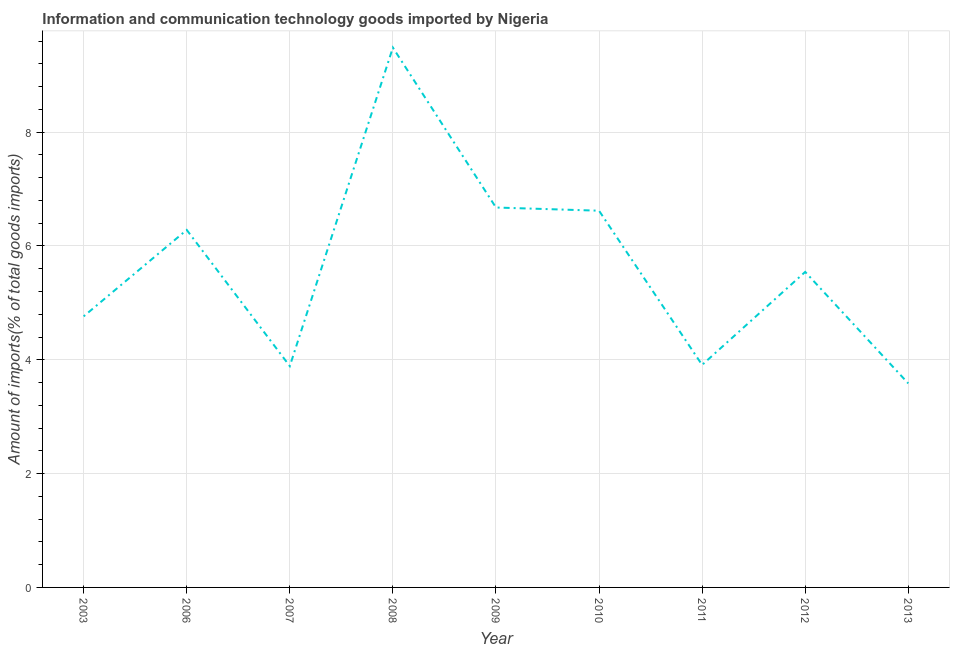What is the amount of ict goods imports in 2010?
Offer a very short reply. 6.62. Across all years, what is the maximum amount of ict goods imports?
Offer a very short reply. 9.49. Across all years, what is the minimum amount of ict goods imports?
Offer a very short reply. 3.59. In which year was the amount of ict goods imports minimum?
Your answer should be very brief. 2013. What is the sum of the amount of ict goods imports?
Your answer should be compact. 50.76. What is the difference between the amount of ict goods imports in 2011 and 2013?
Offer a terse response. 0.32. What is the average amount of ict goods imports per year?
Your answer should be compact. 5.64. What is the median amount of ict goods imports?
Provide a succinct answer. 5.54. Do a majority of the years between 2012 and 2007 (inclusive) have amount of ict goods imports greater than 6.8 %?
Offer a very short reply. Yes. What is the ratio of the amount of ict goods imports in 2011 to that in 2013?
Keep it short and to the point. 1.09. Is the amount of ict goods imports in 2007 less than that in 2013?
Your answer should be compact. No. What is the difference between the highest and the second highest amount of ict goods imports?
Give a very brief answer. 2.81. Is the sum of the amount of ict goods imports in 2009 and 2010 greater than the maximum amount of ict goods imports across all years?
Provide a short and direct response. Yes. What is the difference between the highest and the lowest amount of ict goods imports?
Offer a terse response. 5.9. In how many years, is the amount of ict goods imports greater than the average amount of ict goods imports taken over all years?
Give a very brief answer. 4. Does the amount of ict goods imports monotonically increase over the years?
Provide a short and direct response. No. How many lines are there?
Offer a terse response. 1. How many years are there in the graph?
Offer a very short reply. 9. What is the difference between two consecutive major ticks on the Y-axis?
Ensure brevity in your answer.  2. What is the title of the graph?
Your answer should be very brief. Information and communication technology goods imported by Nigeria. What is the label or title of the Y-axis?
Provide a short and direct response. Amount of imports(% of total goods imports). What is the Amount of imports(% of total goods imports) in 2003?
Provide a short and direct response. 4.76. What is the Amount of imports(% of total goods imports) of 2006?
Keep it short and to the point. 6.28. What is the Amount of imports(% of total goods imports) in 2007?
Your response must be concise. 3.89. What is the Amount of imports(% of total goods imports) in 2008?
Offer a very short reply. 9.49. What is the Amount of imports(% of total goods imports) in 2009?
Give a very brief answer. 6.68. What is the Amount of imports(% of total goods imports) in 2010?
Offer a terse response. 6.62. What is the Amount of imports(% of total goods imports) of 2011?
Your response must be concise. 3.91. What is the Amount of imports(% of total goods imports) of 2012?
Your response must be concise. 5.54. What is the Amount of imports(% of total goods imports) in 2013?
Give a very brief answer. 3.59. What is the difference between the Amount of imports(% of total goods imports) in 2003 and 2006?
Ensure brevity in your answer.  -1.52. What is the difference between the Amount of imports(% of total goods imports) in 2003 and 2007?
Offer a very short reply. 0.87. What is the difference between the Amount of imports(% of total goods imports) in 2003 and 2008?
Make the answer very short. -4.72. What is the difference between the Amount of imports(% of total goods imports) in 2003 and 2009?
Keep it short and to the point. -1.91. What is the difference between the Amount of imports(% of total goods imports) in 2003 and 2010?
Make the answer very short. -1.86. What is the difference between the Amount of imports(% of total goods imports) in 2003 and 2011?
Ensure brevity in your answer.  0.85. What is the difference between the Amount of imports(% of total goods imports) in 2003 and 2012?
Your answer should be compact. -0.78. What is the difference between the Amount of imports(% of total goods imports) in 2003 and 2013?
Make the answer very short. 1.18. What is the difference between the Amount of imports(% of total goods imports) in 2006 and 2007?
Your answer should be very brief. 2.39. What is the difference between the Amount of imports(% of total goods imports) in 2006 and 2008?
Your answer should be very brief. -3.2. What is the difference between the Amount of imports(% of total goods imports) in 2006 and 2009?
Provide a short and direct response. -0.39. What is the difference between the Amount of imports(% of total goods imports) in 2006 and 2010?
Offer a terse response. -0.34. What is the difference between the Amount of imports(% of total goods imports) in 2006 and 2011?
Offer a terse response. 2.37. What is the difference between the Amount of imports(% of total goods imports) in 2006 and 2012?
Provide a short and direct response. 0.74. What is the difference between the Amount of imports(% of total goods imports) in 2006 and 2013?
Give a very brief answer. 2.7. What is the difference between the Amount of imports(% of total goods imports) in 2007 and 2008?
Keep it short and to the point. -5.6. What is the difference between the Amount of imports(% of total goods imports) in 2007 and 2009?
Offer a terse response. -2.79. What is the difference between the Amount of imports(% of total goods imports) in 2007 and 2010?
Your response must be concise. -2.73. What is the difference between the Amount of imports(% of total goods imports) in 2007 and 2011?
Offer a very short reply. -0.02. What is the difference between the Amount of imports(% of total goods imports) in 2007 and 2012?
Offer a terse response. -1.66. What is the difference between the Amount of imports(% of total goods imports) in 2007 and 2013?
Make the answer very short. 0.3. What is the difference between the Amount of imports(% of total goods imports) in 2008 and 2009?
Your response must be concise. 2.81. What is the difference between the Amount of imports(% of total goods imports) in 2008 and 2010?
Make the answer very short. 2.87. What is the difference between the Amount of imports(% of total goods imports) in 2008 and 2011?
Make the answer very short. 5.58. What is the difference between the Amount of imports(% of total goods imports) in 2008 and 2012?
Keep it short and to the point. 3.94. What is the difference between the Amount of imports(% of total goods imports) in 2008 and 2013?
Offer a very short reply. 5.9. What is the difference between the Amount of imports(% of total goods imports) in 2009 and 2010?
Give a very brief answer. 0.06. What is the difference between the Amount of imports(% of total goods imports) in 2009 and 2011?
Offer a very short reply. 2.77. What is the difference between the Amount of imports(% of total goods imports) in 2009 and 2012?
Offer a terse response. 1.13. What is the difference between the Amount of imports(% of total goods imports) in 2009 and 2013?
Provide a succinct answer. 3.09. What is the difference between the Amount of imports(% of total goods imports) in 2010 and 2011?
Ensure brevity in your answer.  2.71. What is the difference between the Amount of imports(% of total goods imports) in 2010 and 2012?
Your answer should be compact. 1.08. What is the difference between the Amount of imports(% of total goods imports) in 2010 and 2013?
Make the answer very short. 3.03. What is the difference between the Amount of imports(% of total goods imports) in 2011 and 2012?
Offer a terse response. -1.63. What is the difference between the Amount of imports(% of total goods imports) in 2011 and 2013?
Give a very brief answer. 0.32. What is the difference between the Amount of imports(% of total goods imports) in 2012 and 2013?
Give a very brief answer. 1.96. What is the ratio of the Amount of imports(% of total goods imports) in 2003 to that in 2006?
Keep it short and to the point. 0.76. What is the ratio of the Amount of imports(% of total goods imports) in 2003 to that in 2007?
Offer a very short reply. 1.23. What is the ratio of the Amount of imports(% of total goods imports) in 2003 to that in 2008?
Keep it short and to the point. 0.5. What is the ratio of the Amount of imports(% of total goods imports) in 2003 to that in 2009?
Offer a terse response. 0.71. What is the ratio of the Amount of imports(% of total goods imports) in 2003 to that in 2010?
Your answer should be compact. 0.72. What is the ratio of the Amount of imports(% of total goods imports) in 2003 to that in 2011?
Keep it short and to the point. 1.22. What is the ratio of the Amount of imports(% of total goods imports) in 2003 to that in 2012?
Offer a very short reply. 0.86. What is the ratio of the Amount of imports(% of total goods imports) in 2003 to that in 2013?
Make the answer very short. 1.33. What is the ratio of the Amount of imports(% of total goods imports) in 2006 to that in 2007?
Your answer should be very brief. 1.61. What is the ratio of the Amount of imports(% of total goods imports) in 2006 to that in 2008?
Provide a short and direct response. 0.66. What is the ratio of the Amount of imports(% of total goods imports) in 2006 to that in 2009?
Your response must be concise. 0.94. What is the ratio of the Amount of imports(% of total goods imports) in 2006 to that in 2010?
Your response must be concise. 0.95. What is the ratio of the Amount of imports(% of total goods imports) in 2006 to that in 2011?
Ensure brevity in your answer.  1.61. What is the ratio of the Amount of imports(% of total goods imports) in 2006 to that in 2012?
Provide a short and direct response. 1.13. What is the ratio of the Amount of imports(% of total goods imports) in 2006 to that in 2013?
Your answer should be compact. 1.75. What is the ratio of the Amount of imports(% of total goods imports) in 2007 to that in 2008?
Provide a succinct answer. 0.41. What is the ratio of the Amount of imports(% of total goods imports) in 2007 to that in 2009?
Make the answer very short. 0.58. What is the ratio of the Amount of imports(% of total goods imports) in 2007 to that in 2010?
Your answer should be compact. 0.59. What is the ratio of the Amount of imports(% of total goods imports) in 2007 to that in 2012?
Your answer should be very brief. 0.7. What is the ratio of the Amount of imports(% of total goods imports) in 2007 to that in 2013?
Ensure brevity in your answer.  1.08. What is the ratio of the Amount of imports(% of total goods imports) in 2008 to that in 2009?
Make the answer very short. 1.42. What is the ratio of the Amount of imports(% of total goods imports) in 2008 to that in 2010?
Your response must be concise. 1.43. What is the ratio of the Amount of imports(% of total goods imports) in 2008 to that in 2011?
Keep it short and to the point. 2.43. What is the ratio of the Amount of imports(% of total goods imports) in 2008 to that in 2012?
Give a very brief answer. 1.71. What is the ratio of the Amount of imports(% of total goods imports) in 2008 to that in 2013?
Your answer should be compact. 2.65. What is the ratio of the Amount of imports(% of total goods imports) in 2009 to that in 2010?
Your response must be concise. 1.01. What is the ratio of the Amount of imports(% of total goods imports) in 2009 to that in 2011?
Your answer should be compact. 1.71. What is the ratio of the Amount of imports(% of total goods imports) in 2009 to that in 2012?
Give a very brief answer. 1.2. What is the ratio of the Amount of imports(% of total goods imports) in 2009 to that in 2013?
Offer a terse response. 1.86. What is the ratio of the Amount of imports(% of total goods imports) in 2010 to that in 2011?
Your answer should be compact. 1.69. What is the ratio of the Amount of imports(% of total goods imports) in 2010 to that in 2012?
Give a very brief answer. 1.19. What is the ratio of the Amount of imports(% of total goods imports) in 2010 to that in 2013?
Your answer should be very brief. 1.85. What is the ratio of the Amount of imports(% of total goods imports) in 2011 to that in 2012?
Provide a short and direct response. 0.7. What is the ratio of the Amount of imports(% of total goods imports) in 2011 to that in 2013?
Offer a terse response. 1.09. What is the ratio of the Amount of imports(% of total goods imports) in 2012 to that in 2013?
Keep it short and to the point. 1.55. 